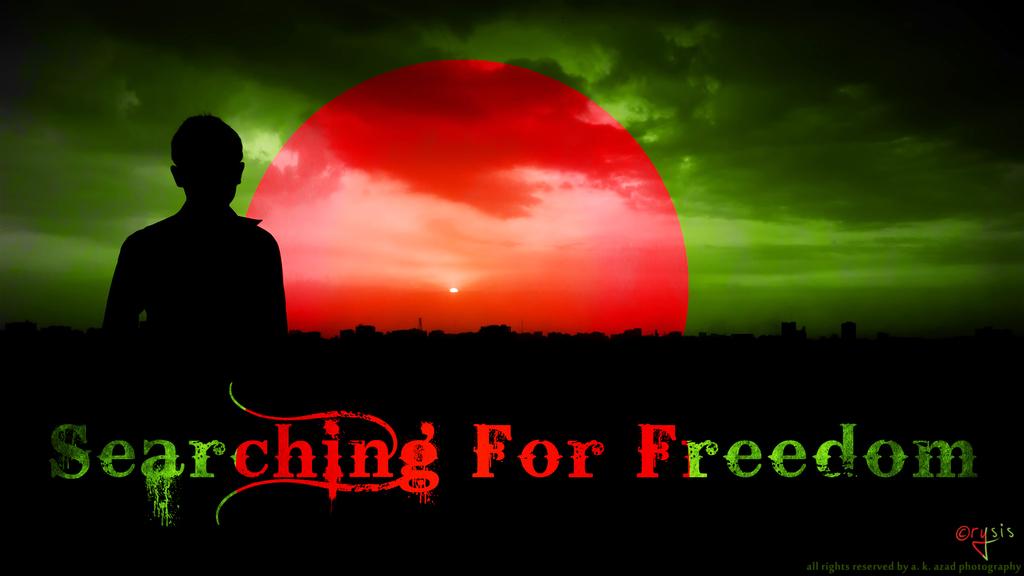What are they searching for?
Provide a succinct answer. Freedom. What is the title of the poster?
Offer a very short reply. Searching for freedom. 